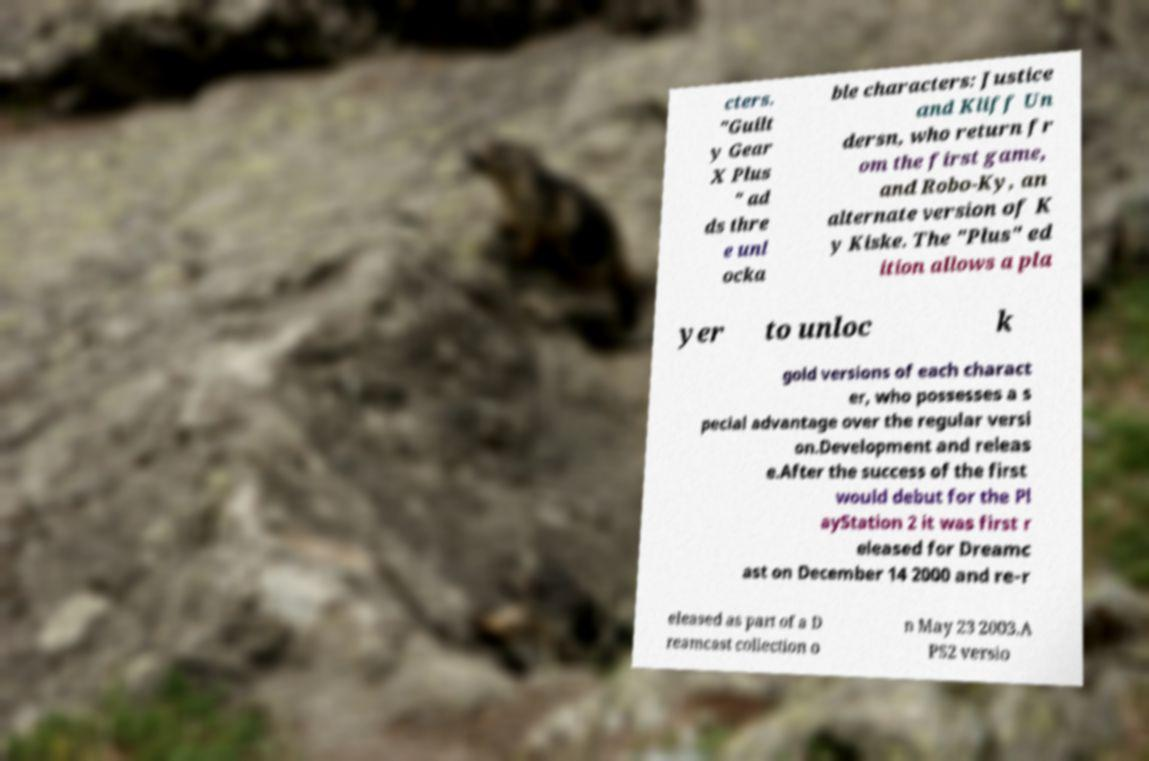There's text embedded in this image that I need extracted. Can you transcribe it verbatim? cters. "Guilt y Gear X Plus " ad ds thre e unl ocka ble characters: Justice and Kliff Un dersn, who return fr om the first game, and Robo-Ky, an alternate version of K y Kiske. The "Plus" ed ition allows a pla yer to unloc k gold versions of each charact er, who possesses a s pecial advantage over the regular versi on.Development and releas e.After the success of the first would debut for the Pl ayStation 2 it was first r eleased for Dreamc ast on December 14 2000 and re-r eleased as part of a D reamcast collection o n May 23 2003.A PS2 versio 